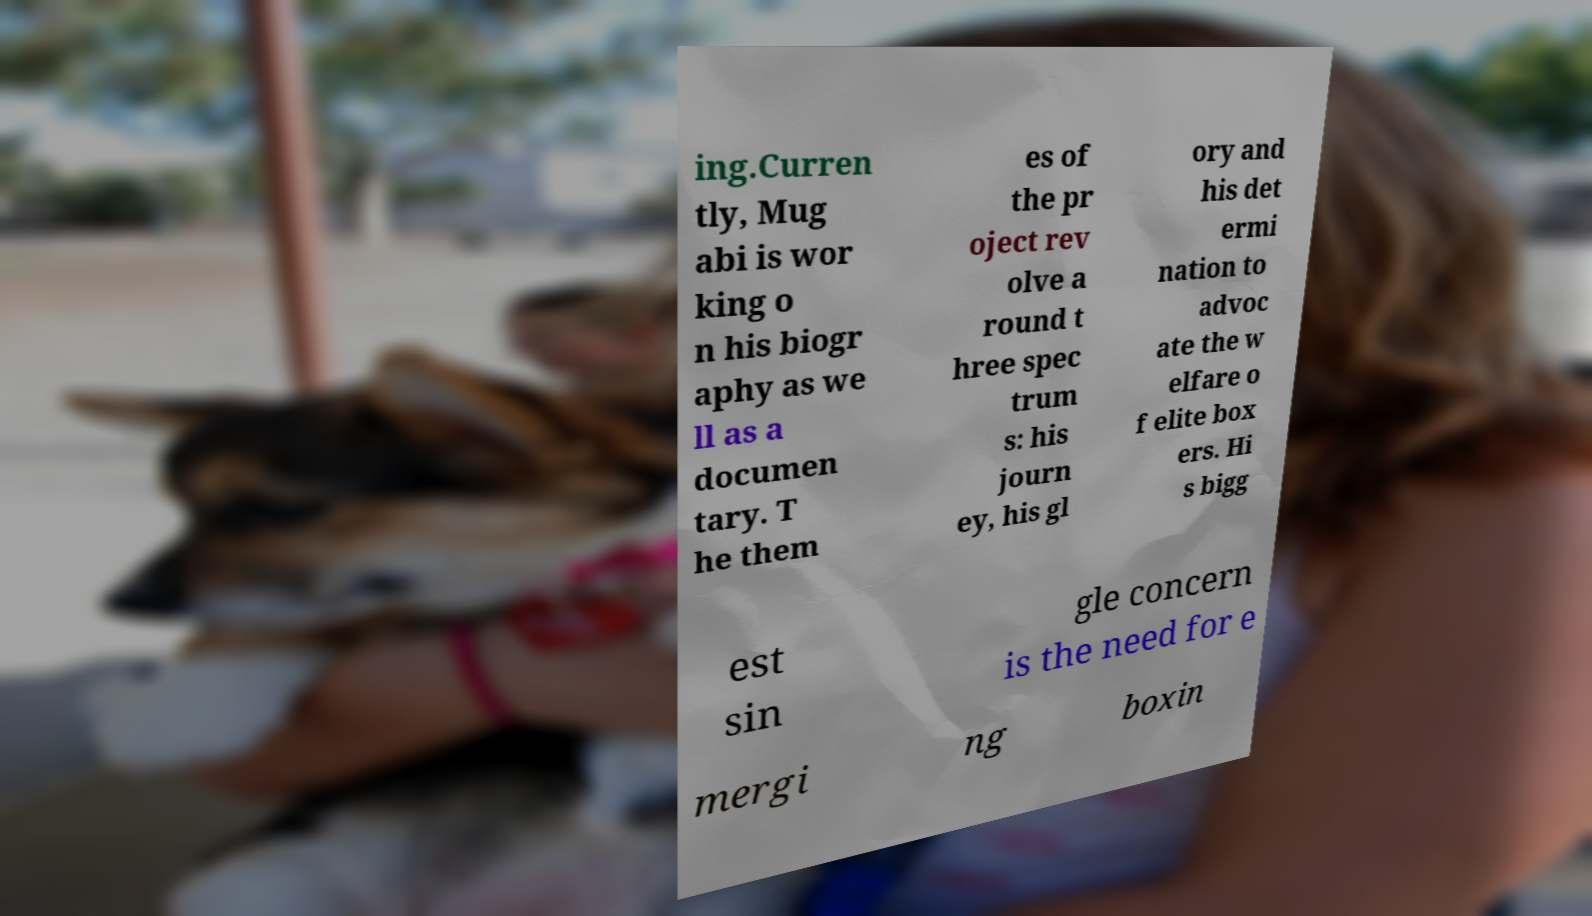Could you assist in decoding the text presented in this image and type it out clearly? ing.Curren tly, Mug abi is wor king o n his biogr aphy as we ll as a documen tary. T he them es of the pr oject rev olve a round t hree spec trum s: his journ ey, his gl ory and his det ermi nation to advoc ate the w elfare o f elite box ers. Hi s bigg est sin gle concern is the need for e mergi ng boxin 